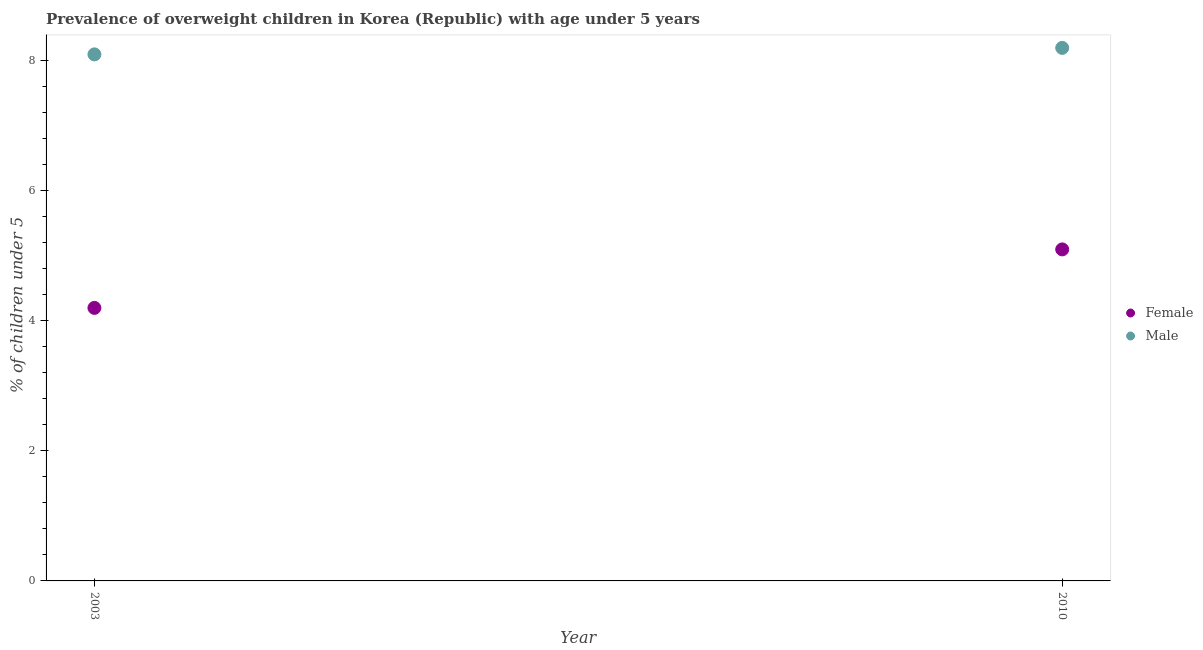How many different coloured dotlines are there?
Provide a short and direct response. 2. Is the number of dotlines equal to the number of legend labels?
Ensure brevity in your answer.  Yes. What is the percentage of obese female children in 2003?
Provide a succinct answer. 4.2. Across all years, what is the maximum percentage of obese female children?
Give a very brief answer. 5.1. Across all years, what is the minimum percentage of obese female children?
Provide a succinct answer. 4.2. In which year was the percentage of obese female children minimum?
Give a very brief answer. 2003. What is the total percentage of obese female children in the graph?
Keep it short and to the point. 9.3. What is the difference between the percentage of obese female children in 2003 and that in 2010?
Your answer should be compact. -0.9. What is the difference between the percentage of obese male children in 2003 and the percentage of obese female children in 2010?
Your answer should be compact. 3. What is the average percentage of obese female children per year?
Give a very brief answer. 4.65. In the year 2003, what is the difference between the percentage of obese male children and percentage of obese female children?
Provide a short and direct response. 3.9. What is the ratio of the percentage of obese female children in 2003 to that in 2010?
Offer a very short reply. 0.82. Is the percentage of obese male children in 2003 less than that in 2010?
Keep it short and to the point. Yes. In how many years, is the percentage of obese male children greater than the average percentage of obese male children taken over all years?
Give a very brief answer. 1. What is the difference between two consecutive major ticks on the Y-axis?
Keep it short and to the point. 2. Are the values on the major ticks of Y-axis written in scientific E-notation?
Provide a short and direct response. No. Does the graph contain grids?
Ensure brevity in your answer.  No. How are the legend labels stacked?
Provide a succinct answer. Vertical. What is the title of the graph?
Provide a short and direct response. Prevalence of overweight children in Korea (Republic) with age under 5 years. Does "Services" appear as one of the legend labels in the graph?
Make the answer very short. No. What is the label or title of the Y-axis?
Your answer should be very brief.  % of children under 5. What is the  % of children under 5 of Female in 2003?
Your answer should be very brief. 4.2. What is the  % of children under 5 in Male in 2003?
Provide a succinct answer. 8.1. What is the  % of children under 5 in Female in 2010?
Ensure brevity in your answer.  5.1. What is the  % of children under 5 in Male in 2010?
Provide a succinct answer. 8.2. Across all years, what is the maximum  % of children under 5 of Female?
Provide a short and direct response. 5.1. Across all years, what is the maximum  % of children under 5 in Male?
Give a very brief answer. 8.2. Across all years, what is the minimum  % of children under 5 in Female?
Your answer should be very brief. 4.2. Across all years, what is the minimum  % of children under 5 in Male?
Ensure brevity in your answer.  8.1. What is the total  % of children under 5 in Female in the graph?
Give a very brief answer. 9.3. What is the difference between the  % of children under 5 of Female in 2003 and that in 2010?
Your response must be concise. -0.9. What is the difference between the  % of children under 5 in Female in 2003 and the  % of children under 5 in Male in 2010?
Your answer should be very brief. -4. What is the average  % of children under 5 in Female per year?
Your answer should be very brief. 4.65. What is the average  % of children under 5 of Male per year?
Keep it short and to the point. 8.15. In the year 2003, what is the difference between the  % of children under 5 in Female and  % of children under 5 in Male?
Make the answer very short. -3.9. In the year 2010, what is the difference between the  % of children under 5 of Female and  % of children under 5 of Male?
Give a very brief answer. -3.1. What is the ratio of the  % of children under 5 in Female in 2003 to that in 2010?
Make the answer very short. 0.82. What is the ratio of the  % of children under 5 in Male in 2003 to that in 2010?
Offer a very short reply. 0.99. 